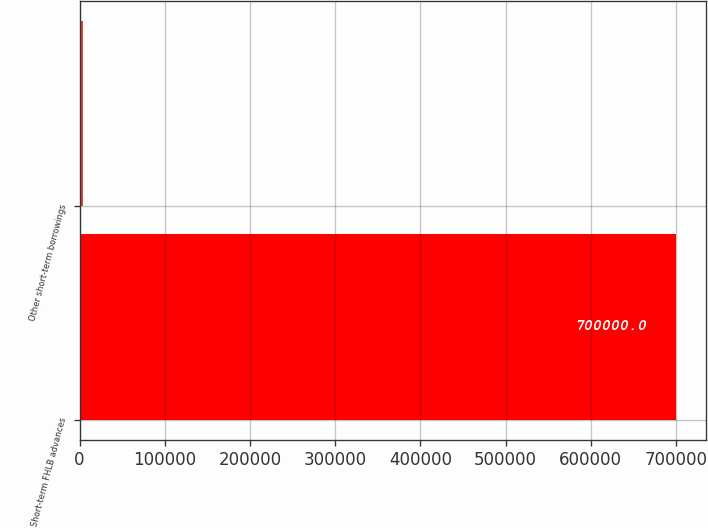Convert chart to OTSL. <chart><loc_0><loc_0><loc_500><loc_500><bar_chart><fcel>Short-term FHLB advances<fcel>Other short-term borrowings<nl><fcel>700000<fcel>3730<nl></chart> 